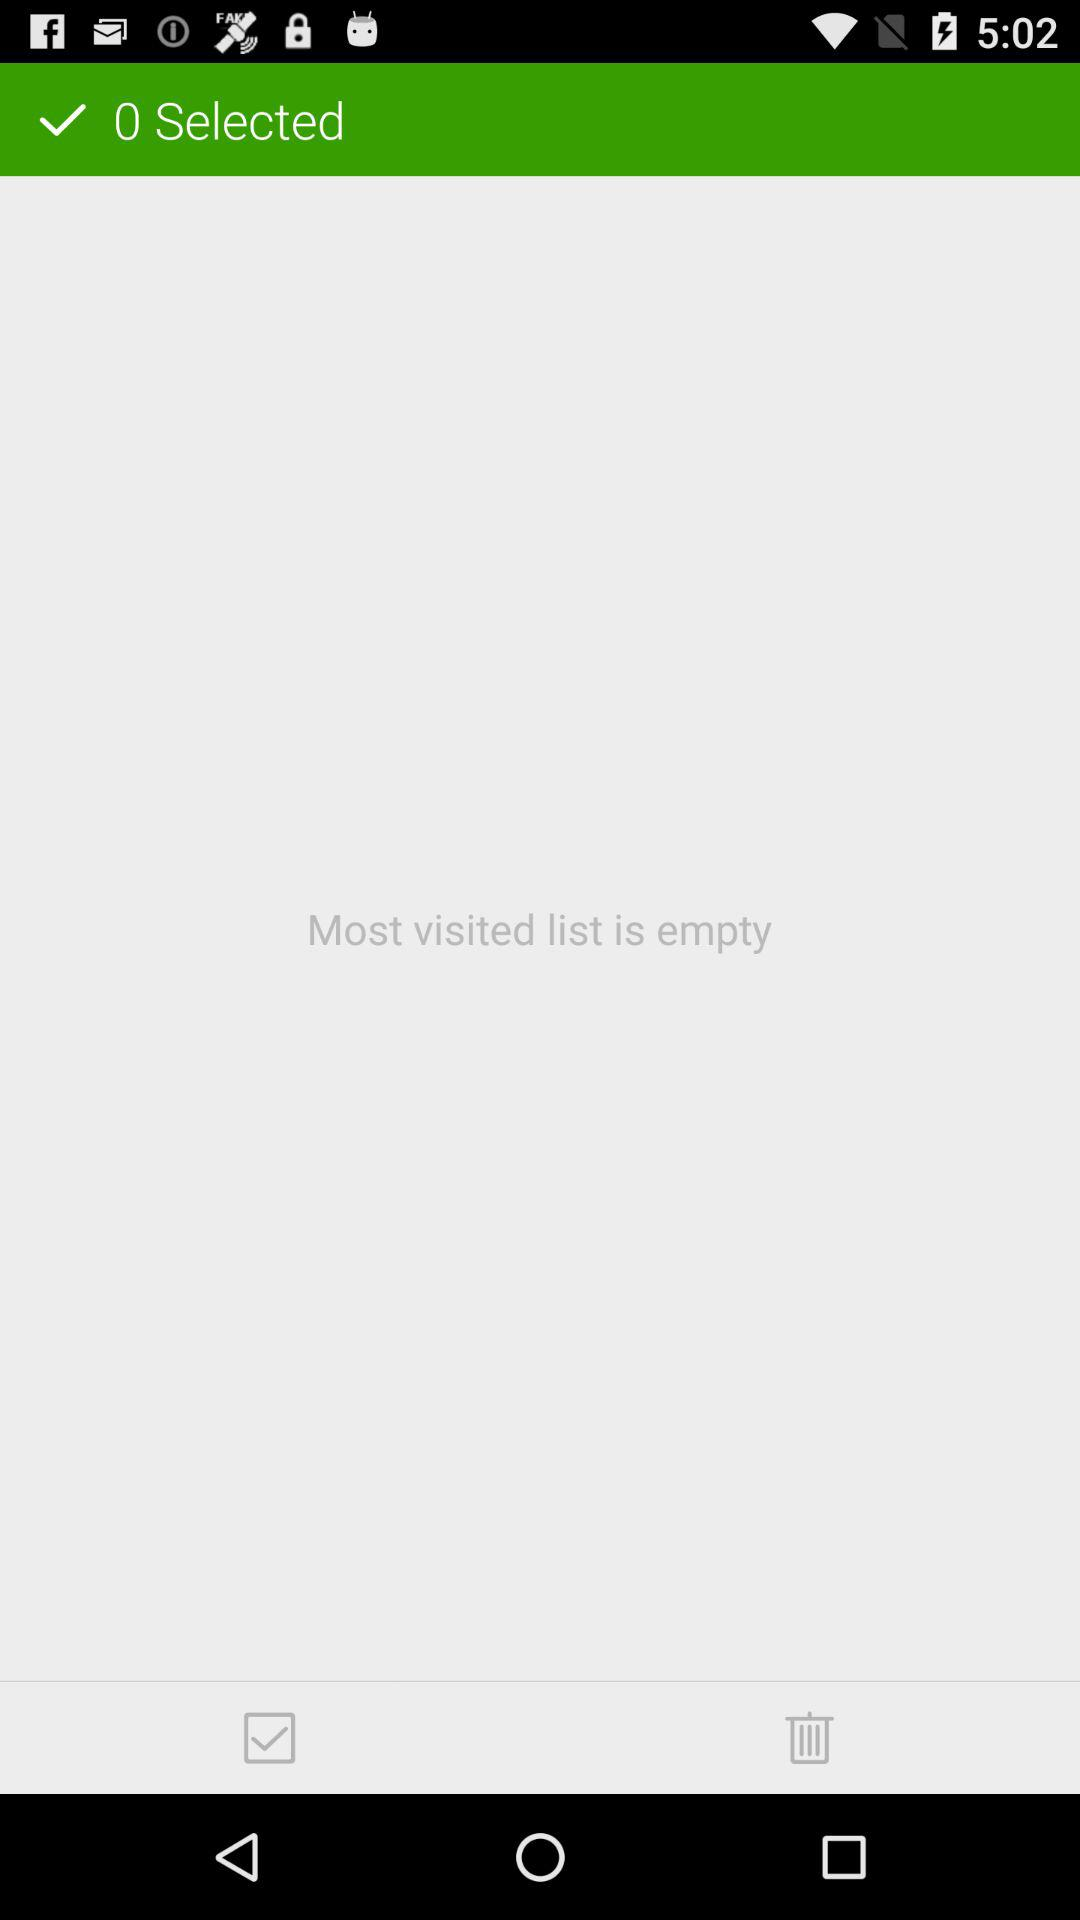How many items were deleted?
When the provided information is insufficient, respond with <no answer>. <no answer> 